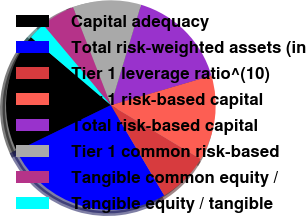<chart> <loc_0><loc_0><loc_500><loc_500><pie_chart><fcel>Capital adequacy<fcel>Total risk-weighted assets (in<fcel>Tier 1 leverage ratio^(10)<fcel>Tier 1 risk-based capital<fcel>Total risk-based capital<fcel>Tier 1 common risk-based<fcel>Tangible common equity /<fcel>Tangible equity / tangible<nl><fcel>18.42%<fcel>26.31%<fcel>7.9%<fcel>13.16%<fcel>15.79%<fcel>10.53%<fcel>5.27%<fcel>2.64%<nl></chart> 